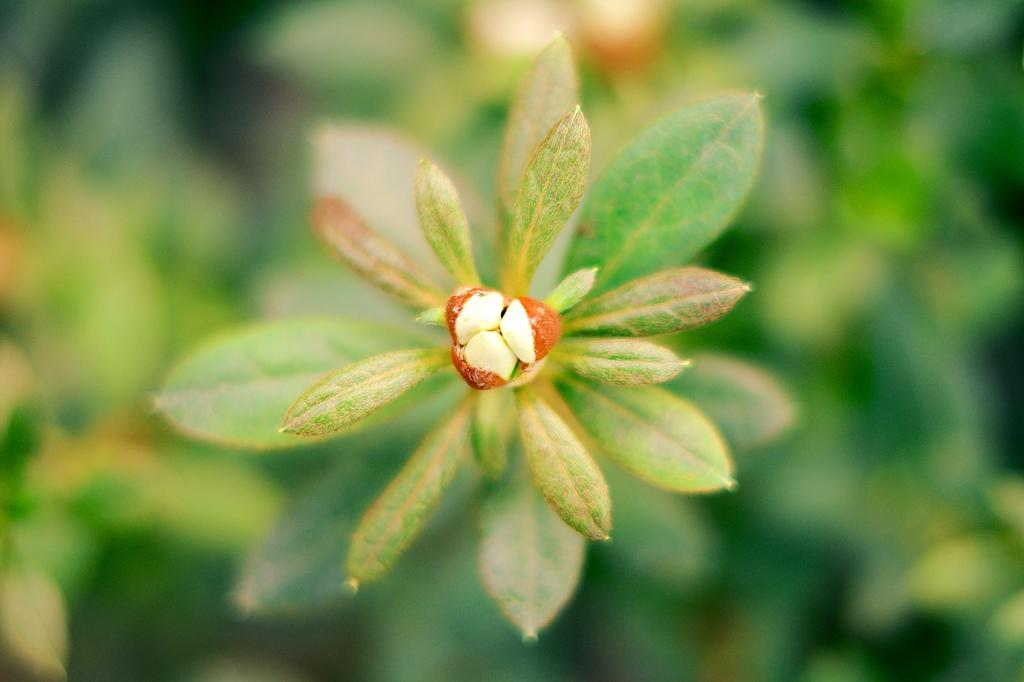Who is the person in the picture? There is a person named Bud in the picture. What is Bud holding in the image? Bud is holding a plant in the picture. Can you describe the background of the image? The background of the image is blurred. What type of grain is visible in the background of the image? There is no grain visible in the background of the image; it is blurred. 